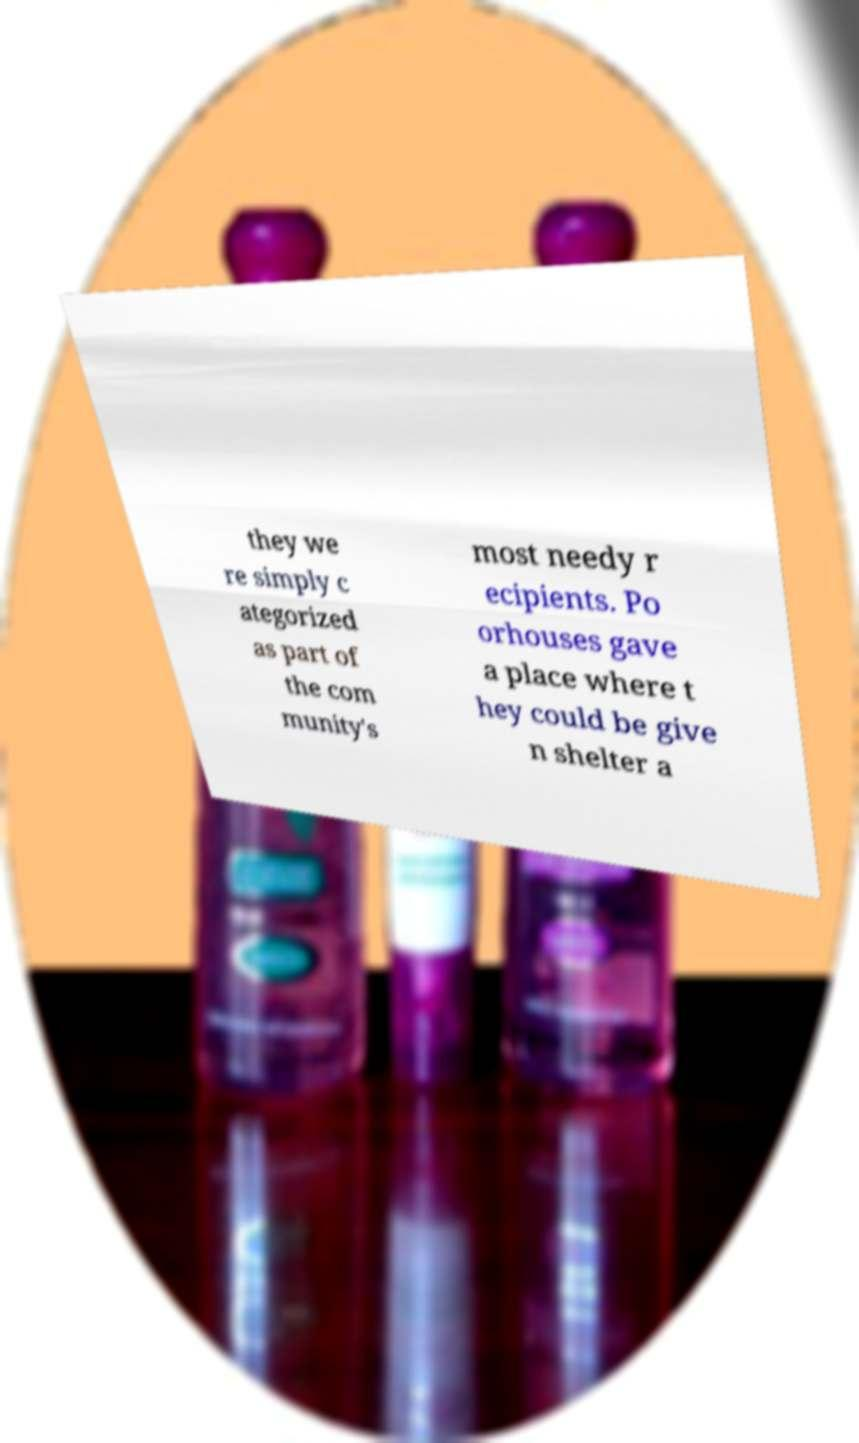Could you assist in decoding the text presented in this image and type it out clearly? they we re simply c ategorized as part of the com munity's most needy r ecipients. Po orhouses gave a place where t hey could be give n shelter a 